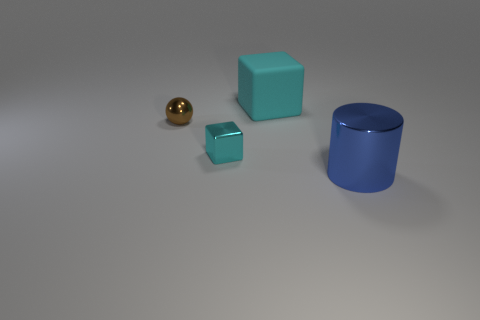The small cyan thing that is the same material as the brown sphere is what shape?
Keep it short and to the point. Cube. How many other things are the same shape as the brown shiny thing?
Your answer should be compact. 0. There is a large thing that is in front of the tiny cube; what shape is it?
Your answer should be compact. Cylinder. The tiny metallic sphere has what color?
Provide a succinct answer. Brown. How many other objects are the same size as the blue object?
Provide a short and direct response. 1. The cyan block right of the cyan thing that is in front of the ball is made of what material?
Your answer should be very brief. Rubber. Do the cyan metal object and the cube that is behind the cyan metal cube have the same size?
Give a very brief answer. No. Are there any other tiny blocks that have the same color as the matte block?
Offer a very short reply. Yes. How many big objects are rubber cubes or cylinders?
Your answer should be compact. 2. What number of big cyan cubes are there?
Provide a short and direct response. 1. 